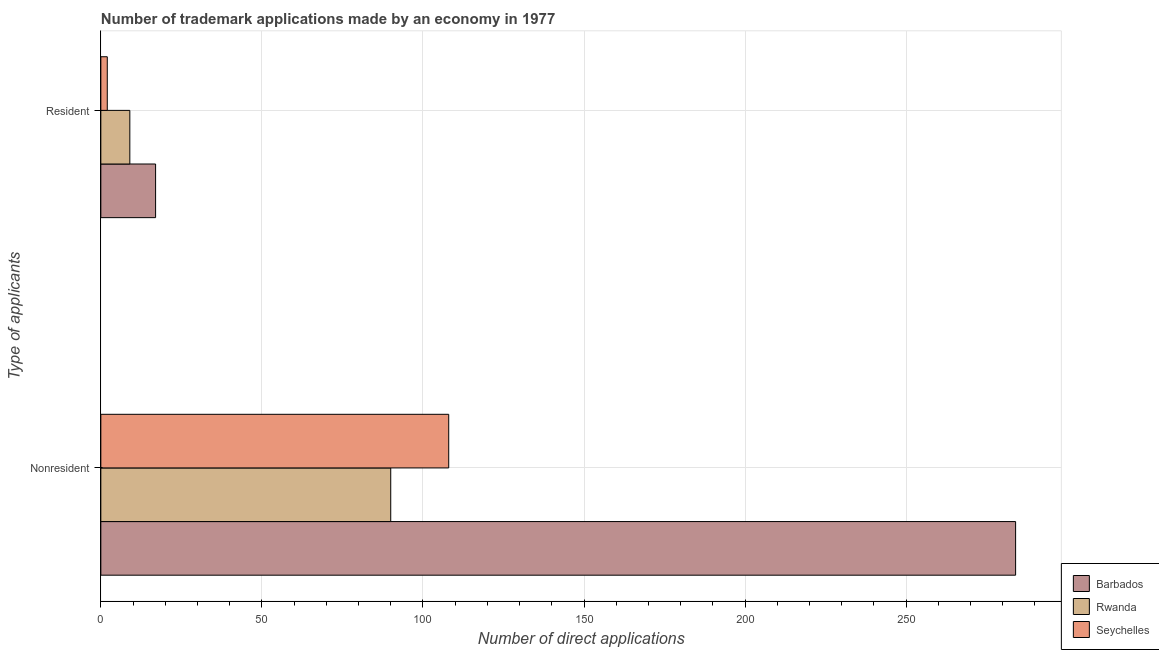How many different coloured bars are there?
Your answer should be very brief. 3. How many bars are there on the 1st tick from the bottom?
Give a very brief answer. 3. What is the label of the 2nd group of bars from the top?
Provide a succinct answer. Nonresident. What is the number of trademark applications made by residents in Seychelles?
Keep it short and to the point. 2. Across all countries, what is the maximum number of trademark applications made by residents?
Ensure brevity in your answer.  17. Across all countries, what is the minimum number of trademark applications made by non residents?
Make the answer very short. 90. In which country was the number of trademark applications made by non residents maximum?
Your response must be concise. Barbados. In which country was the number of trademark applications made by residents minimum?
Provide a succinct answer. Seychelles. What is the total number of trademark applications made by non residents in the graph?
Make the answer very short. 482. What is the difference between the number of trademark applications made by non residents in Rwanda and that in Seychelles?
Offer a very short reply. -18. What is the difference between the number of trademark applications made by non residents in Seychelles and the number of trademark applications made by residents in Barbados?
Offer a terse response. 91. What is the average number of trademark applications made by non residents per country?
Provide a succinct answer. 160.67. What is the difference between the number of trademark applications made by non residents and number of trademark applications made by residents in Rwanda?
Provide a short and direct response. 81. In how many countries, is the number of trademark applications made by residents greater than 100 ?
Provide a succinct answer. 0. What is the ratio of the number of trademark applications made by non residents in Rwanda to that in Seychelles?
Your answer should be compact. 0.83. Is the number of trademark applications made by non residents in Seychelles less than that in Rwanda?
Provide a succinct answer. No. What does the 1st bar from the top in Nonresident represents?
Your response must be concise. Seychelles. What does the 1st bar from the bottom in Nonresident represents?
Your answer should be very brief. Barbados. How many countries are there in the graph?
Provide a succinct answer. 3. What is the difference between two consecutive major ticks on the X-axis?
Your response must be concise. 50. Are the values on the major ticks of X-axis written in scientific E-notation?
Offer a very short reply. No. Does the graph contain any zero values?
Your answer should be very brief. No. What is the title of the graph?
Ensure brevity in your answer.  Number of trademark applications made by an economy in 1977. Does "Central African Republic" appear as one of the legend labels in the graph?
Ensure brevity in your answer.  No. What is the label or title of the X-axis?
Keep it short and to the point. Number of direct applications. What is the label or title of the Y-axis?
Your answer should be compact. Type of applicants. What is the Number of direct applications in Barbados in Nonresident?
Ensure brevity in your answer.  284. What is the Number of direct applications in Rwanda in Nonresident?
Provide a short and direct response. 90. What is the Number of direct applications of Seychelles in Nonresident?
Your answer should be very brief. 108. What is the Number of direct applications of Barbados in Resident?
Offer a terse response. 17. What is the Number of direct applications of Rwanda in Resident?
Offer a very short reply. 9. Across all Type of applicants, what is the maximum Number of direct applications in Barbados?
Make the answer very short. 284. Across all Type of applicants, what is the maximum Number of direct applications in Seychelles?
Offer a very short reply. 108. Across all Type of applicants, what is the minimum Number of direct applications in Barbados?
Provide a short and direct response. 17. Across all Type of applicants, what is the minimum Number of direct applications in Seychelles?
Your answer should be compact. 2. What is the total Number of direct applications in Barbados in the graph?
Make the answer very short. 301. What is the total Number of direct applications of Rwanda in the graph?
Your answer should be very brief. 99. What is the total Number of direct applications in Seychelles in the graph?
Provide a short and direct response. 110. What is the difference between the Number of direct applications of Barbados in Nonresident and that in Resident?
Make the answer very short. 267. What is the difference between the Number of direct applications of Rwanda in Nonresident and that in Resident?
Offer a terse response. 81. What is the difference between the Number of direct applications in Seychelles in Nonresident and that in Resident?
Keep it short and to the point. 106. What is the difference between the Number of direct applications in Barbados in Nonresident and the Number of direct applications in Rwanda in Resident?
Ensure brevity in your answer.  275. What is the difference between the Number of direct applications in Barbados in Nonresident and the Number of direct applications in Seychelles in Resident?
Your answer should be very brief. 282. What is the difference between the Number of direct applications of Rwanda in Nonresident and the Number of direct applications of Seychelles in Resident?
Your answer should be very brief. 88. What is the average Number of direct applications in Barbados per Type of applicants?
Your response must be concise. 150.5. What is the average Number of direct applications of Rwanda per Type of applicants?
Give a very brief answer. 49.5. What is the average Number of direct applications in Seychelles per Type of applicants?
Keep it short and to the point. 55. What is the difference between the Number of direct applications of Barbados and Number of direct applications of Rwanda in Nonresident?
Provide a succinct answer. 194. What is the difference between the Number of direct applications in Barbados and Number of direct applications in Seychelles in Nonresident?
Offer a very short reply. 176. What is the ratio of the Number of direct applications in Barbados in Nonresident to that in Resident?
Offer a very short reply. 16.71. What is the ratio of the Number of direct applications of Rwanda in Nonresident to that in Resident?
Your response must be concise. 10. What is the difference between the highest and the second highest Number of direct applications of Barbados?
Your response must be concise. 267. What is the difference between the highest and the second highest Number of direct applications of Seychelles?
Your response must be concise. 106. What is the difference between the highest and the lowest Number of direct applications of Barbados?
Provide a succinct answer. 267. What is the difference between the highest and the lowest Number of direct applications in Seychelles?
Offer a terse response. 106. 